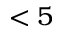Convert formula to latex. <formula><loc_0><loc_0><loc_500><loc_500>< 5</formula> 